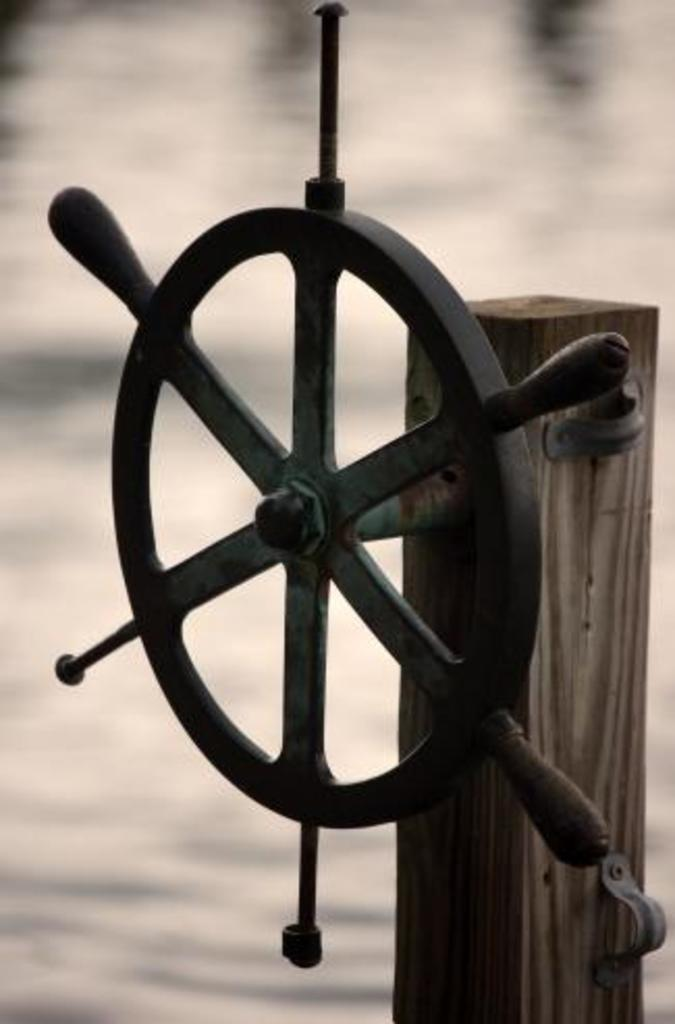What is the color of the steering wheel in the image? The steering wheel in the image is black. How is the steering wheel attached to the wooden pole? The steering wheel is fixed to a wooden pole. What can be seen in the background of the image? There is water visible in the background of the image. How many tigers can be seen swimming in the water in the image? There are no tigers present in the image; only a black steering wheel and a wooden pole are visible. 